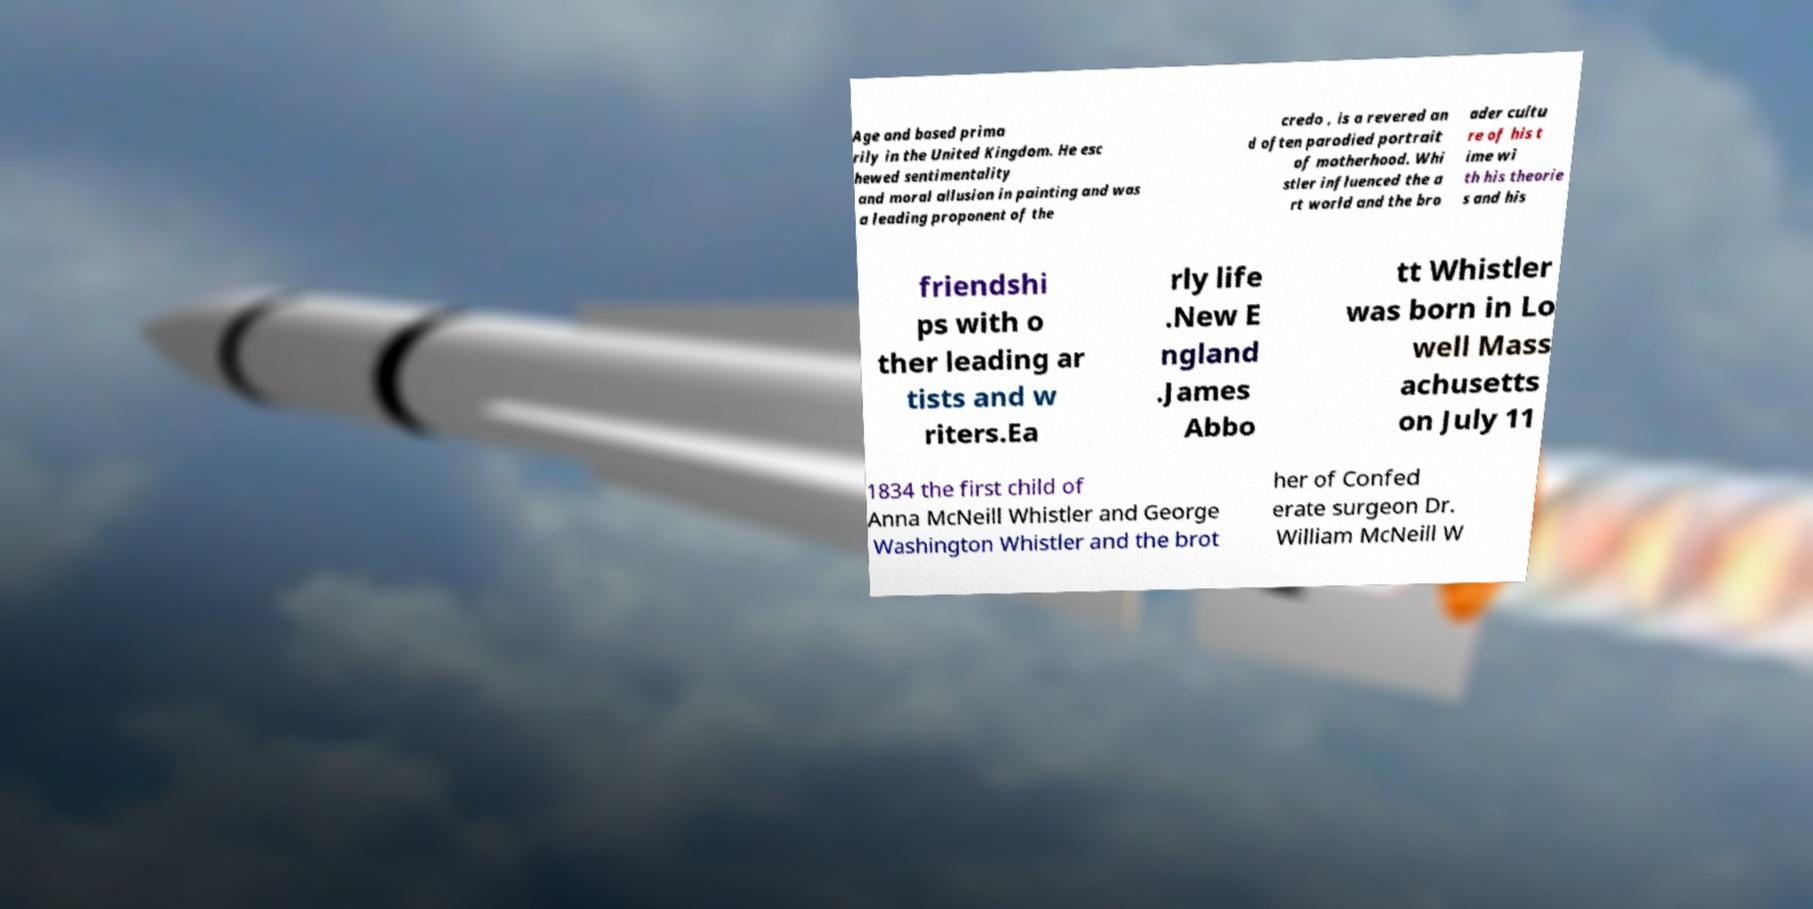Could you assist in decoding the text presented in this image and type it out clearly? Age and based prima rily in the United Kingdom. He esc hewed sentimentality and moral allusion in painting and was a leading proponent of the credo , is a revered an d often parodied portrait of motherhood. Whi stler influenced the a rt world and the bro ader cultu re of his t ime wi th his theorie s and his friendshi ps with o ther leading ar tists and w riters.Ea rly life .New E ngland .James Abbo tt Whistler was born in Lo well Mass achusetts on July 11 1834 the first child of Anna McNeill Whistler and George Washington Whistler and the brot her of Confed erate surgeon Dr. William McNeill W 